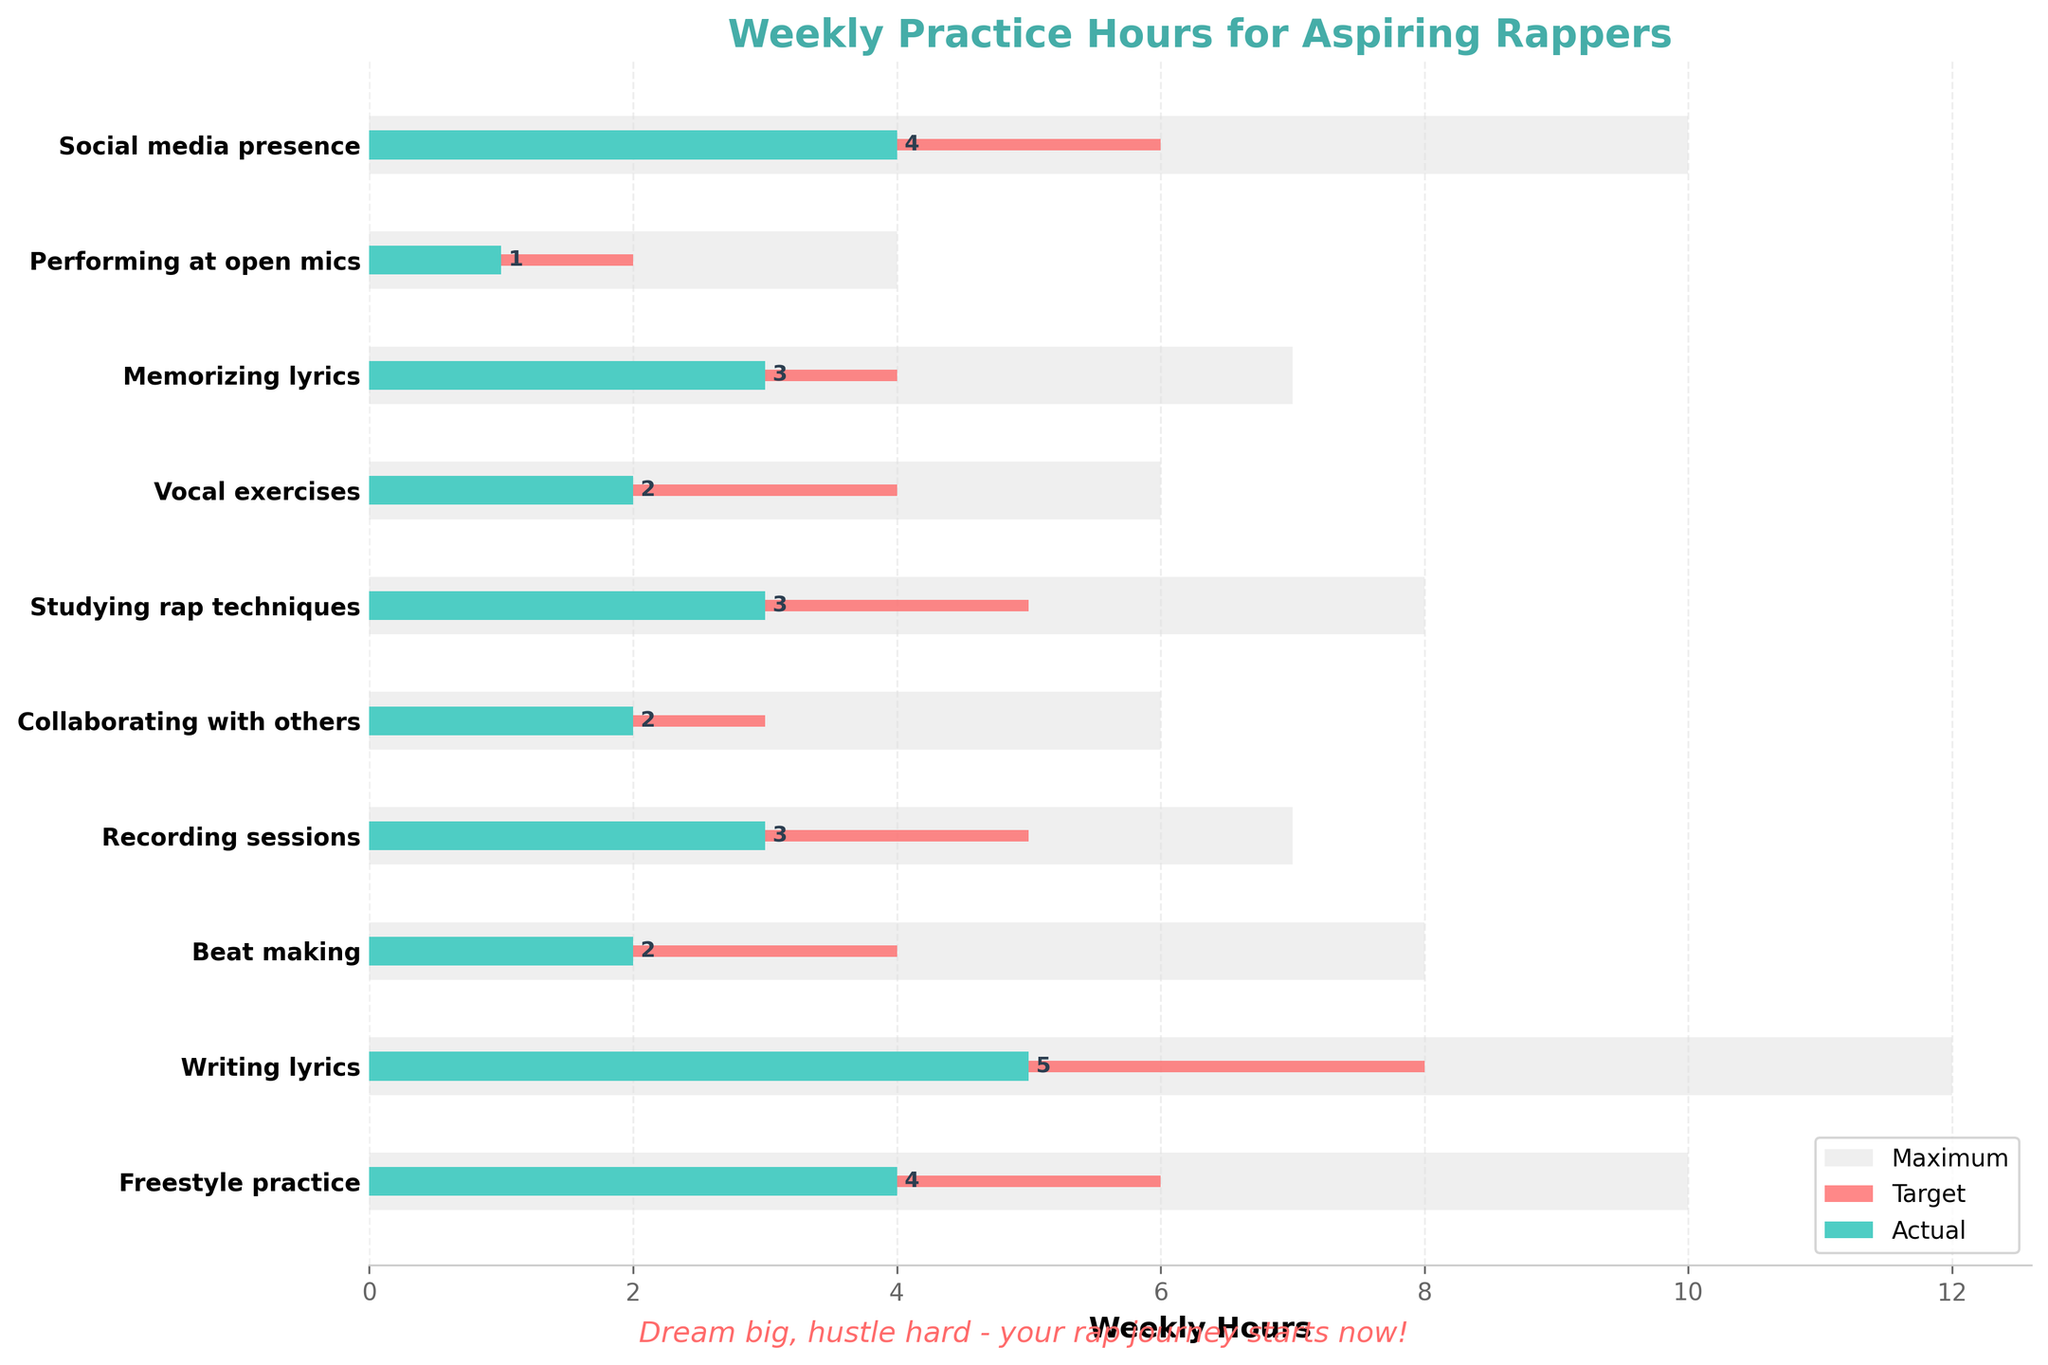What's the title of the plot? The title of the plot is located at the top center of the figure and is written in bold. It reads "Weekly Practice Hours for Aspiring Rappers".
Answer: Weekly Practice Hours for Aspiring Rappers How many categories are being compared in the figure? The categories are listed along the y-axis, one per data point. Counting them provides the answer.
Answer: 10 Which practice category has the highest 'Actual' hours? By examining the green bars representing the 'Actual' hours, "Writing lyrics" stands out as the longest bar.
Answer: Writing lyrics What is the average 'Target' time across all categories? Sum the 'Target' values (6+8+4+5+3+5+4+4+2+6) which equals 47, and divide by the number of categories, which is 10.
Answer: 4.7 Compare the 'Actual' and 'Target' hours for "Performing at open mics". Are they the same? For "Performing at open mics", the 'Target' is 2 and the 'Actual' is 1. These values are not the same.
Answer: No Which category has the smallest difference between 'Actual' and 'Target' hours? The difference for each category can be calculated. "Memorizing lyrics" has the smallest difference:
Answer: Memorizing lyrics How many categories have 'Actual' hours that are more than half of their 'Target' hours? Check each category to see if the 'Actual' is more than 50% of the 'Target'. For example, "Social media presence" with 4 out of 6. Repeat for all categories to get the count, which results in half the categories (5 out of 10).
Answer: 5 For the category "Freestyle practice", is the 'Actual' closer to the 'Target' or the 'Max'? Calculate the differences between 'Actual' (4) and both 'Target' (6) and 'Max' (10). 10 - 4 = 6 and 6 - 4 = 2. The 'Actual' is closer to the 'Target'.
Answer: Target What is the total 'Max' hours for all categories? Sum the 'Max' values for each category (10+12+8+7+6+8+6+7+4+10) to get 78.
Answer: 78 